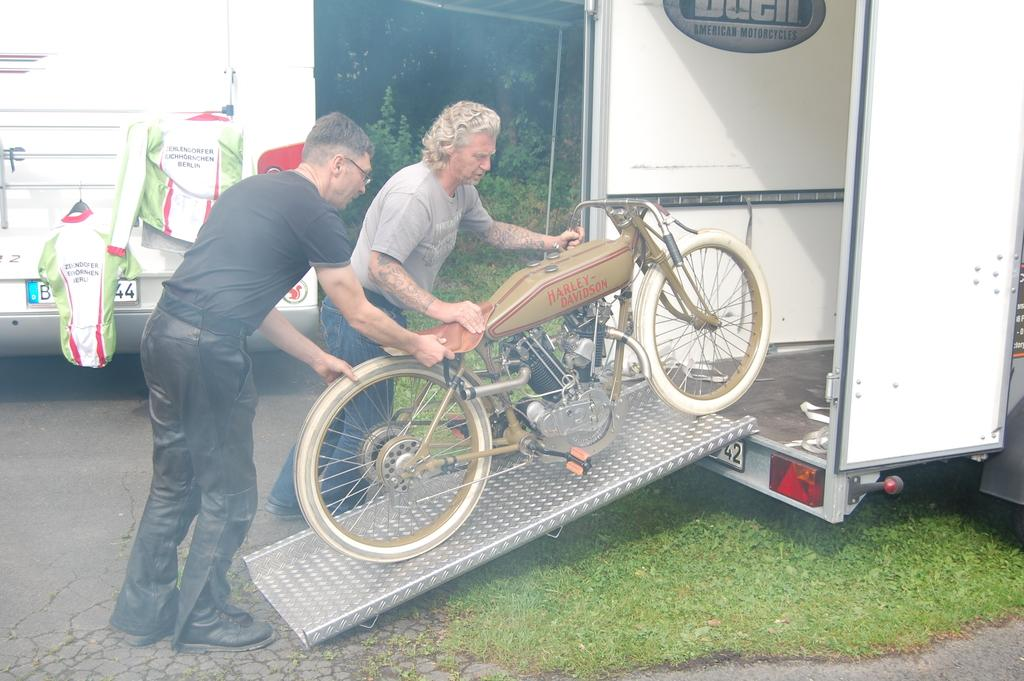How many people are in the image? There are two men in the image. What are the men doing in the image? The men are pushing a motorcycle. What is the motorcycle being pushed into? The motorcycle is being pushed into a trolley. What type of terrain is visible at the bottom of the image? There is grass at the bottom of the image. What can be seen in the background of the image? There is a bus and clothes visible in the background, as well as trees. What type of brick can be seen floating in the sea in the image? There is no brick or sea present in the image; it features two men pushing a motorcycle into a trolley on grass, with a bus and trees visible in the background. 